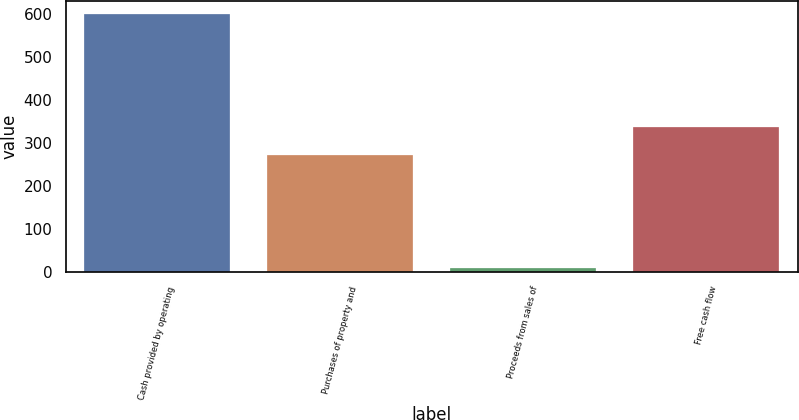Convert chart to OTSL. <chart><loc_0><loc_0><loc_500><loc_500><bar_chart><fcel>Cash provided by operating<fcel>Purchases of property and<fcel>Proceeds from sales of<fcel>Free cash flow<nl><fcel>600.5<fcel>273.2<fcel>9.1<fcel>336.4<nl></chart> 